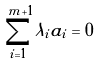Convert formula to latex. <formula><loc_0><loc_0><loc_500><loc_500>\sum _ { i = 1 } ^ { m + 1 } \lambda _ { i } a _ { i } = 0</formula> 